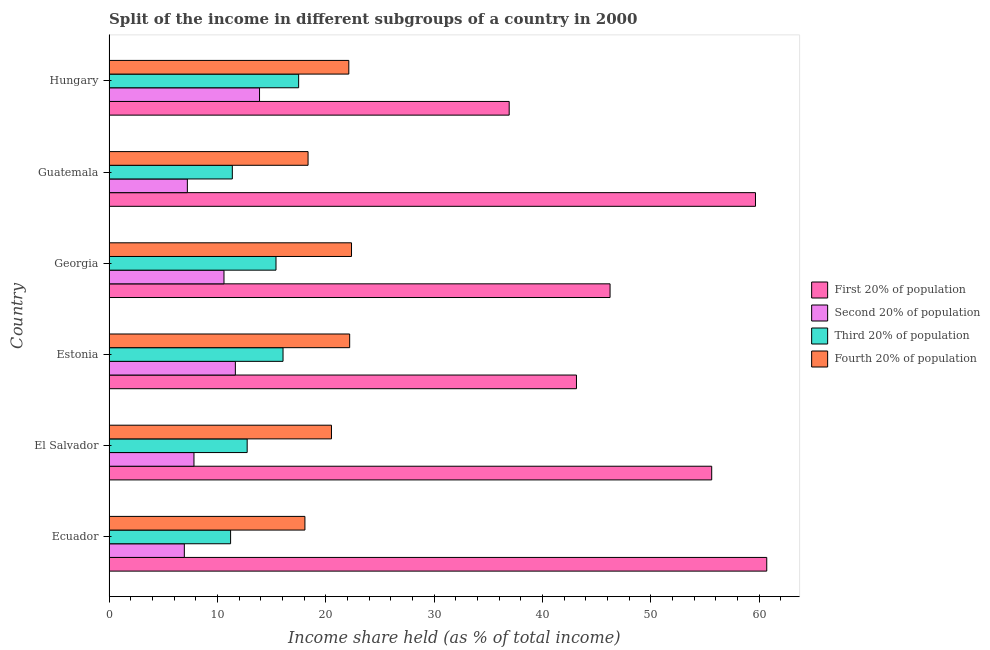Are the number of bars per tick equal to the number of legend labels?
Keep it short and to the point. Yes. How many bars are there on the 1st tick from the top?
Offer a terse response. 4. How many bars are there on the 3rd tick from the bottom?
Your response must be concise. 4. What is the label of the 1st group of bars from the top?
Make the answer very short. Hungary. In how many cases, is the number of bars for a given country not equal to the number of legend labels?
Give a very brief answer. 0. Across all countries, what is the maximum share of the income held by first 20% of the population?
Your response must be concise. 60.7. Across all countries, what is the minimum share of the income held by fourth 20% of the population?
Provide a succinct answer. 18.08. In which country was the share of the income held by second 20% of the population maximum?
Give a very brief answer. Hungary. In which country was the share of the income held by fourth 20% of the population minimum?
Make the answer very short. Ecuador. What is the total share of the income held by fourth 20% of the population in the graph?
Offer a very short reply. 123.7. What is the difference between the share of the income held by second 20% of the population in Estonia and that in Guatemala?
Your answer should be very brief. 4.43. What is the difference between the share of the income held by fourth 20% of the population in Ecuador and the share of the income held by third 20% of the population in El Salvador?
Ensure brevity in your answer.  5.33. What is the average share of the income held by second 20% of the population per country?
Give a very brief answer. 9.7. What is the difference between the share of the income held by fourth 20% of the population and share of the income held by third 20% of the population in Georgia?
Your response must be concise. 6.97. In how many countries, is the share of the income held by fourth 20% of the population greater than 16 %?
Your response must be concise. 6. What is the ratio of the share of the income held by third 20% of the population in Ecuador to that in Hungary?
Your response must be concise. 0.64. Is the difference between the share of the income held by second 20% of the population in El Salvador and Estonia greater than the difference between the share of the income held by fourth 20% of the population in El Salvador and Estonia?
Keep it short and to the point. No. What is the difference between the highest and the second highest share of the income held by third 20% of the population?
Offer a very short reply. 1.44. What is the difference between the highest and the lowest share of the income held by first 20% of the population?
Offer a terse response. 23.77. In how many countries, is the share of the income held by fourth 20% of the population greater than the average share of the income held by fourth 20% of the population taken over all countries?
Provide a short and direct response. 3. Is the sum of the share of the income held by second 20% of the population in El Salvador and Georgia greater than the maximum share of the income held by first 20% of the population across all countries?
Your response must be concise. No. Is it the case that in every country, the sum of the share of the income held by second 20% of the population and share of the income held by first 20% of the population is greater than the sum of share of the income held by fourth 20% of the population and share of the income held by third 20% of the population?
Give a very brief answer. Yes. What does the 1st bar from the top in Georgia represents?
Offer a very short reply. Fourth 20% of population. What does the 4th bar from the bottom in Estonia represents?
Ensure brevity in your answer.  Fourth 20% of population. Is it the case that in every country, the sum of the share of the income held by first 20% of the population and share of the income held by second 20% of the population is greater than the share of the income held by third 20% of the population?
Your answer should be very brief. Yes. What is the difference between two consecutive major ticks on the X-axis?
Offer a very short reply. 10. Are the values on the major ticks of X-axis written in scientific E-notation?
Make the answer very short. No. Does the graph contain any zero values?
Your answer should be very brief. No. How many legend labels are there?
Your response must be concise. 4. How are the legend labels stacked?
Ensure brevity in your answer.  Vertical. What is the title of the graph?
Keep it short and to the point. Split of the income in different subgroups of a country in 2000. What is the label or title of the X-axis?
Your answer should be very brief. Income share held (as % of total income). What is the label or title of the Y-axis?
Offer a very short reply. Country. What is the Income share held (as % of total income) of First 20% of population in Ecuador?
Your answer should be very brief. 60.7. What is the Income share held (as % of total income) in Second 20% of population in Ecuador?
Keep it short and to the point. 6.95. What is the Income share held (as % of total income) in Third 20% of population in Ecuador?
Keep it short and to the point. 11.22. What is the Income share held (as % of total income) of Fourth 20% of population in Ecuador?
Keep it short and to the point. 18.08. What is the Income share held (as % of total income) in First 20% of population in El Salvador?
Your answer should be compact. 55.62. What is the Income share held (as % of total income) in Second 20% of population in El Salvador?
Your response must be concise. 7.84. What is the Income share held (as % of total income) of Third 20% of population in El Salvador?
Offer a very short reply. 12.75. What is the Income share held (as % of total income) in Fourth 20% of population in El Salvador?
Ensure brevity in your answer.  20.53. What is the Income share held (as % of total income) of First 20% of population in Estonia?
Provide a succinct answer. 43.14. What is the Income share held (as % of total income) of Second 20% of population in Estonia?
Make the answer very short. 11.66. What is the Income share held (as % of total income) in Third 20% of population in Estonia?
Provide a short and direct response. 16.06. What is the Income share held (as % of total income) in Fourth 20% of population in Estonia?
Offer a terse response. 22.21. What is the Income share held (as % of total income) of First 20% of population in Georgia?
Provide a short and direct response. 46.24. What is the Income share held (as % of total income) of Second 20% of population in Georgia?
Your answer should be very brief. 10.61. What is the Income share held (as % of total income) of Third 20% of population in Georgia?
Keep it short and to the point. 15.41. What is the Income share held (as % of total income) in Fourth 20% of population in Georgia?
Make the answer very short. 22.38. What is the Income share held (as % of total income) of First 20% of population in Guatemala?
Your response must be concise. 59.66. What is the Income share held (as % of total income) of Second 20% of population in Guatemala?
Your answer should be very brief. 7.23. What is the Income share held (as % of total income) of Third 20% of population in Guatemala?
Your answer should be very brief. 11.38. What is the Income share held (as % of total income) of Fourth 20% of population in Guatemala?
Give a very brief answer. 18.37. What is the Income share held (as % of total income) in First 20% of population in Hungary?
Offer a very short reply. 36.93. What is the Income share held (as % of total income) of Second 20% of population in Hungary?
Your response must be concise. 13.89. What is the Income share held (as % of total income) of Third 20% of population in Hungary?
Ensure brevity in your answer.  17.5. What is the Income share held (as % of total income) in Fourth 20% of population in Hungary?
Keep it short and to the point. 22.13. Across all countries, what is the maximum Income share held (as % of total income) of First 20% of population?
Your response must be concise. 60.7. Across all countries, what is the maximum Income share held (as % of total income) of Second 20% of population?
Ensure brevity in your answer.  13.89. Across all countries, what is the maximum Income share held (as % of total income) in Third 20% of population?
Provide a short and direct response. 17.5. Across all countries, what is the maximum Income share held (as % of total income) in Fourth 20% of population?
Give a very brief answer. 22.38. Across all countries, what is the minimum Income share held (as % of total income) in First 20% of population?
Provide a succinct answer. 36.93. Across all countries, what is the minimum Income share held (as % of total income) in Second 20% of population?
Provide a short and direct response. 6.95. Across all countries, what is the minimum Income share held (as % of total income) of Third 20% of population?
Offer a very short reply. 11.22. Across all countries, what is the minimum Income share held (as % of total income) in Fourth 20% of population?
Give a very brief answer. 18.08. What is the total Income share held (as % of total income) of First 20% of population in the graph?
Your answer should be very brief. 302.29. What is the total Income share held (as % of total income) in Second 20% of population in the graph?
Offer a very short reply. 58.18. What is the total Income share held (as % of total income) in Third 20% of population in the graph?
Ensure brevity in your answer.  84.32. What is the total Income share held (as % of total income) in Fourth 20% of population in the graph?
Your answer should be very brief. 123.7. What is the difference between the Income share held (as % of total income) in First 20% of population in Ecuador and that in El Salvador?
Provide a short and direct response. 5.08. What is the difference between the Income share held (as % of total income) of Second 20% of population in Ecuador and that in El Salvador?
Ensure brevity in your answer.  -0.89. What is the difference between the Income share held (as % of total income) of Third 20% of population in Ecuador and that in El Salvador?
Keep it short and to the point. -1.53. What is the difference between the Income share held (as % of total income) of Fourth 20% of population in Ecuador and that in El Salvador?
Make the answer very short. -2.45. What is the difference between the Income share held (as % of total income) in First 20% of population in Ecuador and that in Estonia?
Provide a succinct answer. 17.56. What is the difference between the Income share held (as % of total income) of Second 20% of population in Ecuador and that in Estonia?
Offer a very short reply. -4.71. What is the difference between the Income share held (as % of total income) of Third 20% of population in Ecuador and that in Estonia?
Ensure brevity in your answer.  -4.84. What is the difference between the Income share held (as % of total income) of Fourth 20% of population in Ecuador and that in Estonia?
Provide a succinct answer. -4.13. What is the difference between the Income share held (as % of total income) in First 20% of population in Ecuador and that in Georgia?
Your answer should be compact. 14.46. What is the difference between the Income share held (as % of total income) in Second 20% of population in Ecuador and that in Georgia?
Your answer should be very brief. -3.66. What is the difference between the Income share held (as % of total income) in Third 20% of population in Ecuador and that in Georgia?
Your answer should be compact. -4.19. What is the difference between the Income share held (as % of total income) of Fourth 20% of population in Ecuador and that in Georgia?
Offer a very short reply. -4.3. What is the difference between the Income share held (as % of total income) of Second 20% of population in Ecuador and that in Guatemala?
Offer a terse response. -0.28. What is the difference between the Income share held (as % of total income) of Third 20% of population in Ecuador and that in Guatemala?
Make the answer very short. -0.16. What is the difference between the Income share held (as % of total income) in Fourth 20% of population in Ecuador and that in Guatemala?
Provide a succinct answer. -0.29. What is the difference between the Income share held (as % of total income) of First 20% of population in Ecuador and that in Hungary?
Provide a succinct answer. 23.77. What is the difference between the Income share held (as % of total income) of Second 20% of population in Ecuador and that in Hungary?
Your answer should be compact. -6.94. What is the difference between the Income share held (as % of total income) of Third 20% of population in Ecuador and that in Hungary?
Offer a terse response. -6.28. What is the difference between the Income share held (as % of total income) of Fourth 20% of population in Ecuador and that in Hungary?
Give a very brief answer. -4.05. What is the difference between the Income share held (as % of total income) in First 20% of population in El Salvador and that in Estonia?
Provide a succinct answer. 12.48. What is the difference between the Income share held (as % of total income) of Second 20% of population in El Salvador and that in Estonia?
Provide a short and direct response. -3.82. What is the difference between the Income share held (as % of total income) of Third 20% of population in El Salvador and that in Estonia?
Provide a succinct answer. -3.31. What is the difference between the Income share held (as % of total income) in Fourth 20% of population in El Salvador and that in Estonia?
Your answer should be very brief. -1.68. What is the difference between the Income share held (as % of total income) of First 20% of population in El Salvador and that in Georgia?
Ensure brevity in your answer.  9.38. What is the difference between the Income share held (as % of total income) in Second 20% of population in El Salvador and that in Georgia?
Your response must be concise. -2.77. What is the difference between the Income share held (as % of total income) of Third 20% of population in El Salvador and that in Georgia?
Your response must be concise. -2.66. What is the difference between the Income share held (as % of total income) of Fourth 20% of population in El Salvador and that in Georgia?
Give a very brief answer. -1.85. What is the difference between the Income share held (as % of total income) in First 20% of population in El Salvador and that in Guatemala?
Your response must be concise. -4.04. What is the difference between the Income share held (as % of total income) of Second 20% of population in El Salvador and that in Guatemala?
Provide a short and direct response. 0.61. What is the difference between the Income share held (as % of total income) of Third 20% of population in El Salvador and that in Guatemala?
Your answer should be very brief. 1.37. What is the difference between the Income share held (as % of total income) of Fourth 20% of population in El Salvador and that in Guatemala?
Offer a terse response. 2.16. What is the difference between the Income share held (as % of total income) of First 20% of population in El Salvador and that in Hungary?
Offer a very short reply. 18.69. What is the difference between the Income share held (as % of total income) of Second 20% of population in El Salvador and that in Hungary?
Give a very brief answer. -6.05. What is the difference between the Income share held (as % of total income) in Third 20% of population in El Salvador and that in Hungary?
Offer a very short reply. -4.75. What is the difference between the Income share held (as % of total income) in First 20% of population in Estonia and that in Georgia?
Ensure brevity in your answer.  -3.1. What is the difference between the Income share held (as % of total income) of Third 20% of population in Estonia and that in Georgia?
Your response must be concise. 0.65. What is the difference between the Income share held (as % of total income) in Fourth 20% of population in Estonia and that in Georgia?
Provide a succinct answer. -0.17. What is the difference between the Income share held (as % of total income) of First 20% of population in Estonia and that in Guatemala?
Ensure brevity in your answer.  -16.52. What is the difference between the Income share held (as % of total income) in Second 20% of population in Estonia and that in Guatemala?
Ensure brevity in your answer.  4.43. What is the difference between the Income share held (as % of total income) of Third 20% of population in Estonia and that in Guatemala?
Provide a short and direct response. 4.68. What is the difference between the Income share held (as % of total income) of Fourth 20% of population in Estonia and that in Guatemala?
Offer a terse response. 3.84. What is the difference between the Income share held (as % of total income) of First 20% of population in Estonia and that in Hungary?
Offer a terse response. 6.21. What is the difference between the Income share held (as % of total income) of Second 20% of population in Estonia and that in Hungary?
Make the answer very short. -2.23. What is the difference between the Income share held (as % of total income) of Third 20% of population in Estonia and that in Hungary?
Your answer should be compact. -1.44. What is the difference between the Income share held (as % of total income) in Fourth 20% of population in Estonia and that in Hungary?
Your response must be concise. 0.08. What is the difference between the Income share held (as % of total income) in First 20% of population in Georgia and that in Guatemala?
Give a very brief answer. -13.42. What is the difference between the Income share held (as % of total income) of Second 20% of population in Georgia and that in Guatemala?
Provide a short and direct response. 3.38. What is the difference between the Income share held (as % of total income) of Third 20% of population in Georgia and that in Guatemala?
Offer a terse response. 4.03. What is the difference between the Income share held (as % of total income) in Fourth 20% of population in Georgia and that in Guatemala?
Give a very brief answer. 4.01. What is the difference between the Income share held (as % of total income) in First 20% of population in Georgia and that in Hungary?
Make the answer very short. 9.31. What is the difference between the Income share held (as % of total income) in Second 20% of population in Georgia and that in Hungary?
Offer a terse response. -3.28. What is the difference between the Income share held (as % of total income) in Third 20% of population in Georgia and that in Hungary?
Offer a terse response. -2.09. What is the difference between the Income share held (as % of total income) in First 20% of population in Guatemala and that in Hungary?
Provide a succinct answer. 22.73. What is the difference between the Income share held (as % of total income) in Second 20% of population in Guatemala and that in Hungary?
Keep it short and to the point. -6.66. What is the difference between the Income share held (as % of total income) in Third 20% of population in Guatemala and that in Hungary?
Your answer should be very brief. -6.12. What is the difference between the Income share held (as % of total income) of Fourth 20% of population in Guatemala and that in Hungary?
Offer a terse response. -3.76. What is the difference between the Income share held (as % of total income) of First 20% of population in Ecuador and the Income share held (as % of total income) of Second 20% of population in El Salvador?
Provide a short and direct response. 52.86. What is the difference between the Income share held (as % of total income) of First 20% of population in Ecuador and the Income share held (as % of total income) of Third 20% of population in El Salvador?
Ensure brevity in your answer.  47.95. What is the difference between the Income share held (as % of total income) of First 20% of population in Ecuador and the Income share held (as % of total income) of Fourth 20% of population in El Salvador?
Keep it short and to the point. 40.17. What is the difference between the Income share held (as % of total income) in Second 20% of population in Ecuador and the Income share held (as % of total income) in Fourth 20% of population in El Salvador?
Keep it short and to the point. -13.58. What is the difference between the Income share held (as % of total income) of Third 20% of population in Ecuador and the Income share held (as % of total income) of Fourth 20% of population in El Salvador?
Provide a succinct answer. -9.31. What is the difference between the Income share held (as % of total income) in First 20% of population in Ecuador and the Income share held (as % of total income) in Second 20% of population in Estonia?
Your answer should be compact. 49.04. What is the difference between the Income share held (as % of total income) of First 20% of population in Ecuador and the Income share held (as % of total income) of Third 20% of population in Estonia?
Provide a short and direct response. 44.64. What is the difference between the Income share held (as % of total income) in First 20% of population in Ecuador and the Income share held (as % of total income) in Fourth 20% of population in Estonia?
Give a very brief answer. 38.49. What is the difference between the Income share held (as % of total income) of Second 20% of population in Ecuador and the Income share held (as % of total income) of Third 20% of population in Estonia?
Provide a short and direct response. -9.11. What is the difference between the Income share held (as % of total income) of Second 20% of population in Ecuador and the Income share held (as % of total income) of Fourth 20% of population in Estonia?
Offer a very short reply. -15.26. What is the difference between the Income share held (as % of total income) of Third 20% of population in Ecuador and the Income share held (as % of total income) of Fourth 20% of population in Estonia?
Ensure brevity in your answer.  -10.99. What is the difference between the Income share held (as % of total income) of First 20% of population in Ecuador and the Income share held (as % of total income) of Second 20% of population in Georgia?
Offer a very short reply. 50.09. What is the difference between the Income share held (as % of total income) in First 20% of population in Ecuador and the Income share held (as % of total income) in Third 20% of population in Georgia?
Provide a succinct answer. 45.29. What is the difference between the Income share held (as % of total income) of First 20% of population in Ecuador and the Income share held (as % of total income) of Fourth 20% of population in Georgia?
Provide a succinct answer. 38.32. What is the difference between the Income share held (as % of total income) of Second 20% of population in Ecuador and the Income share held (as % of total income) of Third 20% of population in Georgia?
Your answer should be compact. -8.46. What is the difference between the Income share held (as % of total income) in Second 20% of population in Ecuador and the Income share held (as % of total income) in Fourth 20% of population in Georgia?
Your answer should be compact. -15.43. What is the difference between the Income share held (as % of total income) in Third 20% of population in Ecuador and the Income share held (as % of total income) in Fourth 20% of population in Georgia?
Provide a short and direct response. -11.16. What is the difference between the Income share held (as % of total income) of First 20% of population in Ecuador and the Income share held (as % of total income) of Second 20% of population in Guatemala?
Keep it short and to the point. 53.47. What is the difference between the Income share held (as % of total income) in First 20% of population in Ecuador and the Income share held (as % of total income) in Third 20% of population in Guatemala?
Keep it short and to the point. 49.32. What is the difference between the Income share held (as % of total income) in First 20% of population in Ecuador and the Income share held (as % of total income) in Fourth 20% of population in Guatemala?
Offer a very short reply. 42.33. What is the difference between the Income share held (as % of total income) in Second 20% of population in Ecuador and the Income share held (as % of total income) in Third 20% of population in Guatemala?
Provide a succinct answer. -4.43. What is the difference between the Income share held (as % of total income) in Second 20% of population in Ecuador and the Income share held (as % of total income) in Fourth 20% of population in Guatemala?
Ensure brevity in your answer.  -11.42. What is the difference between the Income share held (as % of total income) of Third 20% of population in Ecuador and the Income share held (as % of total income) of Fourth 20% of population in Guatemala?
Provide a succinct answer. -7.15. What is the difference between the Income share held (as % of total income) of First 20% of population in Ecuador and the Income share held (as % of total income) of Second 20% of population in Hungary?
Provide a short and direct response. 46.81. What is the difference between the Income share held (as % of total income) in First 20% of population in Ecuador and the Income share held (as % of total income) in Third 20% of population in Hungary?
Keep it short and to the point. 43.2. What is the difference between the Income share held (as % of total income) of First 20% of population in Ecuador and the Income share held (as % of total income) of Fourth 20% of population in Hungary?
Offer a terse response. 38.57. What is the difference between the Income share held (as % of total income) in Second 20% of population in Ecuador and the Income share held (as % of total income) in Third 20% of population in Hungary?
Your answer should be very brief. -10.55. What is the difference between the Income share held (as % of total income) in Second 20% of population in Ecuador and the Income share held (as % of total income) in Fourth 20% of population in Hungary?
Offer a very short reply. -15.18. What is the difference between the Income share held (as % of total income) of Third 20% of population in Ecuador and the Income share held (as % of total income) of Fourth 20% of population in Hungary?
Your answer should be very brief. -10.91. What is the difference between the Income share held (as % of total income) of First 20% of population in El Salvador and the Income share held (as % of total income) of Second 20% of population in Estonia?
Offer a very short reply. 43.96. What is the difference between the Income share held (as % of total income) in First 20% of population in El Salvador and the Income share held (as % of total income) in Third 20% of population in Estonia?
Your answer should be very brief. 39.56. What is the difference between the Income share held (as % of total income) of First 20% of population in El Salvador and the Income share held (as % of total income) of Fourth 20% of population in Estonia?
Provide a short and direct response. 33.41. What is the difference between the Income share held (as % of total income) of Second 20% of population in El Salvador and the Income share held (as % of total income) of Third 20% of population in Estonia?
Make the answer very short. -8.22. What is the difference between the Income share held (as % of total income) of Second 20% of population in El Salvador and the Income share held (as % of total income) of Fourth 20% of population in Estonia?
Offer a terse response. -14.37. What is the difference between the Income share held (as % of total income) of Third 20% of population in El Salvador and the Income share held (as % of total income) of Fourth 20% of population in Estonia?
Offer a very short reply. -9.46. What is the difference between the Income share held (as % of total income) in First 20% of population in El Salvador and the Income share held (as % of total income) in Second 20% of population in Georgia?
Make the answer very short. 45.01. What is the difference between the Income share held (as % of total income) in First 20% of population in El Salvador and the Income share held (as % of total income) in Third 20% of population in Georgia?
Keep it short and to the point. 40.21. What is the difference between the Income share held (as % of total income) in First 20% of population in El Salvador and the Income share held (as % of total income) in Fourth 20% of population in Georgia?
Your answer should be compact. 33.24. What is the difference between the Income share held (as % of total income) of Second 20% of population in El Salvador and the Income share held (as % of total income) of Third 20% of population in Georgia?
Provide a succinct answer. -7.57. What is the difference between the Income share held (as % of total income) of Second 20% of population in El Salvador and the Income share held (as % of total income) of Fourth 20% of population in Georgia?
Keep it short and to the point. -14.54. What is the difference between the Income share held (as % of total income) of Third 20% of population in El Salvador and the Income share held (as % of total income) of Fourth 20% of population in Georgia?
Ensure brevity in your answer.  -9.63. What is the difference between the Income share held (as % of total income) of First 20% of population in El Salvador and the Income share held (as % of total income) of Second 20% of population in Guatemala?
Give a very brief answer. 48.39. What is the difference between the Income share held (as % of total income) in First 20% of population in El Salvador and the Income share held (as % of total income) in Third 20% of population in Guatemala?
Provide a succinct answer. 44.24. What is the difference between the Income share held (as % of total income) of First 20% of population in El Salvador and the Income share held (as % of total income) of Fourth 20% of population in Guatemala?
Provide a short and direct response. 37.25. What is the difference between the Income share held (as % of total income) in Second 20% of population in El Salvador and the Income share held (as % of total income) in Third 20% of population in Guatemala?
Provide a short and direct response. -3.54. What is the difference between the Income share held (as % of total income) of Second 20% of population in El Salvador and the Income share held (as % of total income) of Fourth 20% of population in Guatemala?
Ensure brevity in your answer.  -10.53. What is the difference between the Income share held (as % of total income) in Third 20% of population in El Salvador and the Income share held (as % of total income) in Fourth 20% of population in Guatemala?
Make the answer very short. -5.62. What is the difference between the Income share held (as % of total income) in First 20% of population in El Salvador and the Income share held (as % of total income) in Second 20% of population in Hungary?
Give a very brief answer. 41.73. What is the difference between the Income share held (as % of total income) of First 20% of population in El Salvador and the Income share held (as % of total income) of Third 20% of population in Hungary?
Keep it short and to the point. 38.12. What is the difference between the Income share held (as % of total income) in First 20% of population in El Salvador and the Income share held (as % of total income) in Fourth 20% of population in Hungary?
Give a very brief answer. 33.49. What is the difference between the Income share held (as % of total income) in Second 20% of population in El Salvador and the Income share held (as % of total income) in Third 20% of population in Hungary?
Offer a terse response. -9.66. What is the difference between the Income share held (as % of total income) of Second 20% of population in El Salvador and the Income share held (as % of total income) of Fourth 20% of population in Hungary?
Provide a short and direct response. -14.29. What is the difference between the Income share held (as % of total income) of Third 20% of population in El Salvador and the Income share held (as % of total income) of Fourth 20% of population in Hungary?
Your answer should be compact. -9.38. What is the difference between the Income share held (as % of total income) in First 20% of population in Estonia and the Income share held (as % of total income) in Second 20% of population in Georgia?
Your answer should be very brief. 32.53. What is the difference between the Income share held (as % of total income) in First 20% of population in Estonia and the Income share held (as % of total income) in Third 20% of population in Georgia?
Your response must be concise. 27.73. What is the difference between the Income share held (as % of total income) in First 20% of population in Estonia and the Income share held (as % of total income) in Fourth 20% of population in Georgia?
Ensure brevity in your answer.  20.76. What is the difference between the Income share held (as % of total income) in Second 20% of population in Estonia and the Income share held (as % of total income) in Third 20% of population in Georgia?
Ensure brevity in your answer.  -3.75. What is the difference between the Income share held (as % of total income) in Second 20% of population in Estonia and the Income share held (as % of total income) in Fourth 20% of population in Georgia?
Make the answer very short. -10.72. What is the difference between the Income share held (as % of total income) in Third 20% of population in Estonia and the Income share held (as % of total income) in Fourth 20% of population in Georgia?
Ensure brevity in your answer.  -6.32. What is the difference between the Income share held (as % of total income) of First 20% of population in Estonia and the Income share held (as % of total income) of Second 20% of population in Guatemala?
Ensure brevity in your answer.  35.91. What is the difference between the Income share held (as % of total income) in First 20% of population in Estonia and the Income share held (as % of total income) in Third 20% of population in Guatemala?
Provide a succinct answer. 31.76. What is the difference between the Income share held (as % of total income) of First 20% of population in Estonia and the Income share held (as % of total income) of Fourth 20% of population in Guatemala?
Make the answer very short. 24.77. What is the difference between the Income share held (as % of total income) of Second 20% of population in Estonia and the Income share held (as % of total income) of Third 20% of population in Guatemala?
Provide a succinct answer. 0.28. What is the difference between the Income share held (as % of total income) of Second 20% of population in Estonia and the Income share held (as % of total income) of Fourth 20% of population in Guatemala?
Offer a terse response. -6.71. What is the difference between the Income share held (as % of total income) in Third 20% of population in Estonia and the Income share held (as % of total income) in Fourth 20% of population in Guatemala?
Offer a terse response. -2.31. What is the difference between the Income share held (as % of total income) of First 20% of population in Estonia and the Income share held (as % of total income) of Second 20% of population in Hungary?
Ensure brevity in your answer.  29.25. What is the difference between the Income share held (as % of total income) of First 20% of population in Estonia and the Income share held (as % of total income) of Third 20% of population in Hungary?
Give a very brief answer. 25.64. What is the difference between the Income share held (as % of total income) in First 20% of population in Estonia and the Income share held (as % of total income) in Fourth 20% of population in Hungary?
Provide a short and direct response. 21.01. What is the difference between the Income share held (as % of total income) of Second 20% of population in Estonia and the Income share held (as % of total income) of Third 20% of population in Hungary?
Offer a terse response. -5.84. What is the difference between the Income share held (as % of total income) of Second 20% of population in Estonia and the Income share held (as % of total income) of Fourth 20% of population in Hungary?
Your response must be concise. -10.47. What is the difference between the Income share held (as % of total income) in Third 20% of population in Estonia and the Income share held (as % of total income) in Fourth 20% of population in Hungary?
Make the answer very short. -6.07. What is the difference between the Income share held (as % of total income) of First 20% of population in Georgia and the Income share held (as % of total income) of Second 20% of population in Guatemala?
Provide a short and direct response. 39.01. What is the difference between the Income share held (as % of total income) of First 20% of population in Georgia and the Income share held (as % of total income) of Third 20% of population in Guatemala?
Provide a succinct answer. 34.86. What is the difference between the Income share held (as % of total income) of First 20% of population in Georgia and the Income share held (as % of total income) of Fourth 20% of population in Guatemala?
Make the answer very short. 27.87. What is the difference between the Income share held (as % of total income) of Second 20% of population in Georgia and the Income share held (as % of total income) of Third 20% of population in Guatemala?
Offer a very short reply. -0.77. What is the difference between the Income share held (as % of total income) of Second 20% of population in Georgia and the Income share held (as % of total income) of Fourth 20% of population in Guatemala?
Make the answer very short. -7.76. What is the difference between the Income share held (as % of total income) in Third 20% of population in Georgia and the Income share held (as % of total income) in Fourth 20% of population in Guatemala?
Make the answer very short. -2.96. What is the difference between the Income share held (as % of total income) of First 20% of population in Georgia and the Income share held (as % of total income) of Second 20% of population in Hungary?
Provide a succinct answer. 32.35. What is the difference between the Income share held (as % of total income) of First 20% of population in Georgia and the Income share held (as % of total income) of Third 20% of population in Hungary?
Provide a succinct answer. 28.74. What is the difference between the Income share held (as % of total income) in First 20% of population in Georgia and the Income share held (as % of total income) in Fourth 20% of population in Hungary?
Give a very brief answer. 24.11. What is the difference between the Income share held (as % of total income) of Second 20% of population in Georgia and the Income share held (as % of total income) of Third 20% of population in Hungary?
Your response must be concise. -6.89. What is the difference between the Income share held (as % of total income) of Second 20% of population in Georgia and the Income share held (as % of total income) of Fourth 20% of population in Hungary?
Provide a short and direct response. -11.52. What is the difference between the Income share held (as % of total income) of Third 20% of population in Georgia and the Income share held (as % of total income) of Fourth 20% of population in Hungary?
Your response must be concise. -6.72. What is the difference between the Income share held (as % of total income) of First 20% of population in Guatemala and the Income share held (as % of total income) of Second 20% of population in Hungary?
Offer a terse response. 45.77. What is the difference between the Income share held (as % of total income) of First 20% of population in Guatemala and the Income share held (as % of total income) of Third 20% of population in Hungary?
Provide a succinct answer. 42.16. What is the difference between the Income share held (as % of total income) of First 20% of population in Guatemala and the Income share held (as % of total income) of Fourth 20% of population in Hungary?
Make the answer very short. 37.53. What is the difference between the Income share held (as % of total income) of Second 20% of population in Guatemala and the Income share held (as % of total income) of Third 20% of population in Hungary?
Give a very brief answer. -10.27. What is the difference between the Income share held (as % of total income) in Second 20% of population in Guatemala and the Income share held (as % of total income) in Fourth 20% of population in Hungary?
Your answer should be compact. -14.9. What is the difference between the Income share held (as % of total income) of Third 20% of population in Guatemala and the Income share held (as % of total income) of Fourth 20% of population in Hungary?
Your response must be concise. -10.75. What is the average Income share held (as % of total income) in First 20% of population per country?
Your answer should be compact. 50.38. What is the average Income share held (as % of total income) of Second 20% of population per country?
Provide a succinct answer. 9.7. What is the average Income share held (as % of total income) of Third 20% of population per country?
Make the answer very short. 14.05. What is the average Income share held (as % of total income) in Fourth 20% of population per country?
Keep it short and to the point. 20.62. What is the difference between the Income share held (as % of total income) of First 20% of population and Income share held (as % of total income) of Second 20% of population in Ecuador?
Ensure brevity in your answer.  53.75. What is the difference between the Income share held (as % of total income) in First 20% of population and Income share held (as % of total income) in Third 20% of population in Ecuador?
Keep it short and to the point. 49.48. What is the difference between the Income share held (as % of total income) in First 20% of population and Income share held (as % of total income) in Fourth 20% of population in Ecuador?
Your response must be concise. 42.62. What is the difference between the Income share held (as % of total income) in Second 20% of population and Income share held (as % of total income) in Third 20% of population in Ecuador?
Offer a terse response. -4.27. What is the difference between the Income share held (as % of total income) of Second 20% of population and Income share held (as % of total income) of Fourth 20% of population in Ecuador?
Provide a short and direct response. -11.13. What is the difference between the Income share held (as % of total income) in Third 20% of population and Income share held (as % of total income) in Fourth 20% of population in Ecuador?
Your response must be concise. -6.86. What is the difference between the Income share held (as % of total income) of First 20% of population and Income share held (as % of total income) of Second 20% of population in El Salvador?
Offer a terse response. 47.78. What is the difference between the Income share held (as % of total income) of First 20% of population and Income share held (as % of total income) of Third 20% of population in El Salvador?
Provide a succinct answer. 42.87. What is the difference between the Income share held (as % of total income) of First 20% of population and Income share held (as % of total income) of Fourth 20% of population in El Salvador?
Your answer should be compact. 35.09. What is the difference between the Income share held (as % of total income) of Second 20% of population and Income share held (as % of total income) of Third 20% of population in El Salvador?
Offer a terse response. -4.91. What is the difference between the Income share held (as % of total income) of Second 20% of population and Income share held (as % of total income) of Fourth 20% of population in El Salvador?
Your response must be concise. -12.69. What is the difference between the Income share held (as % of total income) of Third 20% of population and Income share held (as % of total income) of Fourth 20% of population in El Salvador?
Make the answer very short. -7.78. What is the difference between the Income share held (as % of total income) of First 20% of population and Income share held (as % of total income) of Second 20% of population in Estonia?
Your answer should be compact. 31.48. What is the difference between the Income share held (as % of total income) of First 20% of population and Income share held (as % of total income) of Third 20% of population in Estonia?
Your response must be concise. 27.08. What is the difference between the Income share held (as % of total income) of First 20% of population and Income share held (as % of total income) of Fourth 20% of population in Estonia?
Keep it short and to the point. 20.93. What is the difference between the Income share held (as % of total income) in Second 20% of population and Income share held (as % of total income) in Third 20% of population in Estonia?
Give a very brief answer. -4.4. What is the difference between the Income share held (as % of total income) of Second 20% of population and Income share held (as % of total income) of Fourth 20% of population in Estonia?
Provide a succinct answer. -10.55. What is the difference between the Income share held (as % of total income) of Third 20% of population and Income share held (as % of total income) of Fourth 20% of population in Estonia?
Your response must be concise. -6.15. What is the difference between the Income share held (as % of total income) in First 20% of population and Income share held (as % of total income) in Second 20% of population in Georgia?
Provide a succinct answer. 35.63. What is the difference between the Income share held (as % of total income) of First 20% of population and Income share held (as % of total income) of Third 20% of population in Georgia?
Provide a short and direct response. 30.83. What is the difference between the Income share held (as % of total income) of First 20% of population and Income share held (as % of total income) of Fourth 20% of population in Georgia?
Keep it short and to the point. 23.86. What is the difference between the Income share held (as % of total income) of Second 20% of population and Income share held (as % of total income) of Third 20% of population in Georgia?
Provide a succinct answer. -4.8. What is the difference between the Income share held (as % of total income) in Second 20% of population and Income share held (as % of total income) in Fourth 20% of population in Georgia?
Provide a short and direct response. -11.77. What is the difference between the Income share held (as % of total income) in Third 20% of population and Income share held (as % of total income) in Fourth 20% of population in Georgia?
Offer a terse response. -6.97. What is the difference between the Income share held (as % of total income) in First 20% of population and Income share held (as % of total income) in Second 20% of population in Guatemala?
Make the answer very short. 52.43. What is the difference between the Income share held (as % of total income) in First 20% of population and Income share held (as % of total income) in Third 20% of population in Guatemala?
Provide a succinct answer. 48.28. What is the difference between the Income share held (as % of total income) in First 20% of population and Income share held (as % of total income) in Fourth 20% of population in Guatemala?
Provide a short and direct response. 41.29. What is the difference between the Income share held (as % of total income) of Second 20% of population and Income share held (as % of total income) of Third 20% of population in Guatemala?
Your answer should be compact. -4.15. What is the difference between the Income share held (as % of total income) in Second 20% of population and Income share held (as % of total income) in Fourth 20% of population in Guatemala?
Offer a very short reply. -11.14. What is the difference between the Income share held (as % of total income) in Third 20% of population and Income share held (as % of total income) in Fourth 20% of population in Guatemala?
Provide a short and direct response. -6.99. What is the difference between the Income share held (as % of total income) of First 20% of population and Income share held (as % of total income) of Second 20% of population in Hungary?
Make the answer very short. 23.04. What is the difference between the Income share held (as % of total income) in First 20% of population and Income share held (as % of total income) in Third 20% of population in Hungary?
Your answer should be very brief. 19.43. What is the difference between the Income share held (as % of total income) in Second 20% of population and Income share held (as % of total income) in Third 20% of population in Hungary?
Ensure brevity in your answer.  -3.61. What is the difference between the Income share held (as % of total income) of Second 20% of population and Income share held (as % of total income) of Fourth 20% of population in Hungary?
Keep it short and to the point. -8.24. What is the difference between the Income share held (as % of total income) in Third 20% of population and Income share held (as % of total income) in Fourth 20% of population in Hungary?
Ensure brevity in your answer.  -4.63. What is the ratio of the Income share held (as % of total income) of First 20% of population in Ecuador to that in El Salvador?
Provide a short and direct response. 1.09. What is the ratio of the Income share held (as % of total income) in Second 20% of population in Ecuador to that in El Salvador?
Keep it short and to the point. 0.89. What is the ratio of the Income share held (as % of total income) in Third 20% of population in Ecuador to that in El Salvador?
Your answer should be compact. 0.88. What is the ratio of the Income share held (as % of total income) in Fourth 20% of population in Ecuador to that in El Salvador?
Your response must be concise. 0.88. What is the ratio of the Income share held (as % of total income) in First 20% of population in Ecuador to that in Estonia?
Make the answer very short. 1.41. What is the ratio of the Income share held (as % of total income) of Second 20% of population in Ecuador to that in Estonia?
Provide a short and direct response. 0.6. What is the ratio of the Income share held (as % of total income) in Third 20% of population in Ecuador to that in Estonia?
Your response must be concise. 0.7. What is the ratio of the Income share held (as % of total income) in Fourth 20% of population in Ecuador to that in Estonia?
Provide a short and direct response. 0.81. What is the ratio of the Income share held (as % of total income) in First 20% of population in Ecuador to that in Georgia?
Provide a short and direct response. 1.31. What is the ratio of the Income share held (as % of total income) of Second 20% of population in Ecuador to that in Georgia?
Provide a succinct answer. 0.66. What is the ratio of the Income share held (as % of total income) in Third 20% of population in Ecuador to that in Georgia?
Keep it short and to the point. 0.73. What is the ratio of the Income share held (as % of total income) in Fourth 20% of population in Ecuador to that in Georgia?
Provide a succinct answer. 0.81. What is the ratio of the Income share held (as % of total income) in First 20% of population in Ecuador to that in Guatemala?
Provide a short and direct response. 1.02. What is the ratio of the Income share held (as % of total income) of Second 20% of population in Ecuador to that in Guatemala?
Offer a very short reply. 0.96. What is the ratio of the Income share held (as % of total income) in Third 20% of population in Ecuador to that in Guatemala?
Give a very brief answer. 0.99. What is the ratio of the Income share held (as % of total income) of Fourth 20% of population in Ecuador to that in Guatemala?
Ensure brevity in your answer.  0.98. What is the ratio of the Income share held (as % of total income) of First 20% of population in Ecuador to that in Hungary?
Give a very brief answer. 1.64. What is the ratio of the Income share held (as % of total income) in Second 20% of population in Ecuador to that in Hungary?
Offer a terse response. 0.5. What is the ratio of the Income share held (as % of total income) of Third 20% of population in Ecuador to that in Hungary?
Give a very brief answer. 0.64. What is the ratio of the Income share held (as % of total income) of Fourth 20% of population in Ecuador to that in Hungary?
Your answer should be very brief. 0.82. What is the ratio of the Income share held (as % of total income) of First 20% of population in El Salvador to that in Estonia?
Provide a succinct answer. 1.29. What is the ratio of the Income share held (as % of total income) in Second 20% of population in El Salvador to that in Estonia?
Your response must be concise. 0.67. What is the ratio of the Income share held (as % of total income) in Third 20% of population in El Salvador to that in Estonia?
Make the answer very short. 0.79. What is the ratio of the Income share held (as % of total income) of Fourth 20% of population in El Salvador to that in Estonia?
Your response must be concise. 0.92. What is the ratio of the Income share held (as % of total income) of First 20% of population in El Salvador to that in Georgia?
Provide a succinct answer. 1.2. What is the ratio of the Income share held (as % of total income) of Second 20% of population in El Salvador to that in Georgia?
Your answer should be very brief. 0.74. What is the ratio of the Income share held (as % of total income) of Third 20% of population in El Salvador to that in Georgia?
Offer a very short reply. 0.83. What is the ratio of the Income share held (as % of total income) of Fourth 20% of population in El Salvador to that in Georgia?
Your answer should be compact. 0.92. What is the ratio of the Income share held (as % of total income) in First 20% of population in El Salvador to that in Guatemala?
Give a very brief answer. 0.93. What is the ratio of the Income share held (as % of total income) of Second 20% of population in El Salvador to that in Guatemala?
Your answer should be compact. 1.08. What is the ratio of the Income share held (as % of total income) in Third 20% of population in El Salvador to that in Guatemala?
Provide a short and direct response. 1.12. What is the ratio of the Income share held (as % of total income) in Fourth 20% of population in El Salvador to that in Guatemala?
Keep it short and to the point. 1.12. What is the ratio of the Income share held (as % of total income) in First 20% of population in El Salvador to that in Hungary?
Give a very brief answer. 1.51. What is the ratio of the Income share held (as % of total income) of Second 20% of population in El Salvador to that in Hungary?
Your response must be concise. 0.56. What is the ratio of the Income share held (as % of total income) in Third 20% of population in El Salvador to that in Hungary?
Offer a very short reply. 0.73. What is the ratio of the Income share held (as % of total income) in Fourth 20% of population in El Salvador to that in Hungary?
Offer a terse response. 0.93. What is the ratio of the Income share held (as % of total income) of First 20% of population in Estonia to that in Georgia?
Ensure brevity in your answer.  0.93. What is the ratio of the Income share held (as % of total income) in Second 20% of population in Estonia to that in Georgia?
Make the answer very short. 1.1. What is the ratio of the Income share held (as % of total income) of Third 20% of population in Estonia to that in Georgia?
Provide a succinct answer. 1.04. What is the ratio of the Income share held (as % of total income) of First 20% of population in Estonia to that in Guatemala?
Offer a terse response. 0.72. What is the ratio of the Income share held (as % of total income) of Second 20% of population in Estonia to that in Guatemala?
Offer a very short reply. 1.61. What is the ratio of the Income share held (as % of total income) of Third 20% of population in Estonia to that in Guatemala?
Your answer should be very brief. 1.41. What is the ratio of the Income share held (as % of total income) in Fourth 20% of population in Estonia to that in Guatemala?
Ensure brevity in your answer.  1.21. What is the ratio of the Income share held (as % of total income) of First 20% of population in Estonia to that in Hungary?
Give a very brief answer. 1.17. What is the ratio of the Income share held (as % of total income) in Second 20% of population in Estonia to that in Hungary?
Make the answer very short. 0.84. What is the ratio of the Income share held (as % of total income) of Third 20% of population in Estonia to that in Hungary?
Provide a succinct answer. 0.92. What is the ratio of the Income share held (as % of total income) in Fourth 20% of population in Estonia to that in Hungary?
Keep it short and to the point. 1. What is the ratio of the Income share held (as % of total income) in First 20% of population in Georgia to that in Guatemala?
Ensure brevity in your answer.  0.78. What is the ratio of the Income share held (as % of total income) in Second 20% of population in Georgia to that in Guatemala?
Offer a very short reply. 1.47. What is the ratio of the Income share held (as % of total income) in Third 20% of population in Georgia to that in Guatemala?
Your answer should be very brief. 1.35. What is the ratio of the Income share held (as % of total income) of Fourth 20% of population in Georgia to that in Guatemala?
Provide a short and direct response. 1.22. What is the ratio of the Income share held (as % of total income) of First 20% of population in Georgia to that in Hungary?
Provide a short and direct response. 1.25. What is the ratio of the Income share held (as % of total income) in Second 20% of population in Georgia to that in Hungary?
Provide a short and direct response. 0.76. What is the ratio of the Income share held (as % of total income) of Third 20% of population in Georgia to that in Hungary?
Give a very brief answer. 0.88. What is the ratio of the Income share held (as % of total income) in Fourth 20% of population in Georgia to that in Hungary?
Provide a short and direct response. 1.01. What is the ratio of the Income share held (as % of total income) of First 20% of population in Guatemala to that in Hungary?
Give a very brief answer. 1.62. What is the ratio of the Income share held (as % of total income) in Second 20% of population in Guatemala to that in Hungary?
Your answer should be very brief. 0.52. What is the ratio of the Income share held (as % of total income) of Third 20% of population in Guatemala to that in Hungary?
Give a very brief answer. 0.65. What is the ratio of the Income share held (as % of total income) in Fourth 20% of population in Guatemala to that in Hungary?
Keep it short and to the point. 0.83. What is the difference between the highest and the second highest Income share held (as % of total income) of First 20% of population?
Ensure brevity in your answer.  1.04. What is the difference between the highest and the second highest Income share held (as % of total income) in Second 20% of population?
Provide a succinct answer. 2.23. What is the difference between the highest and the second highest Income share held (as % of total income) of Third 20% of population?
Offer a terse response. 1.44. What is the difference between the highest and the second highest Income share held (as % of total income) in Fourth 20% of population?
Provide a short and direct response. 0.17. What is the difference between the highest and the lowest Income share held (as % of total income) in First 20% of population?
Ensure brevity in your answer.  23.77. What is the difference between the highest and the lowest Income share held (as % of total income) of Second 20% of population?
Your answer should be compact. 6.94. What is the difference between the highest and the lowest Income share held (as % of total income) in Third 20% of population?
Make the answer very short. 6.28. What is the difference between the highest and the lowest Income share held (as % of total income) of Fourth 20% of population?
Offer a very short reply. 4.3. 